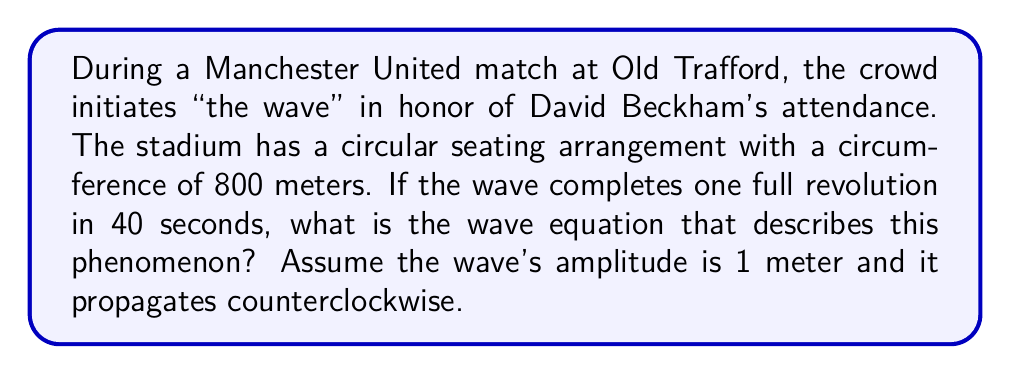What is the answer to this math problem? To derive the wave equation, we'll follow these steps:

1) First, we need to calculate the wave speed:
   $v = \frac{\text{distance}}{\text{time}} = \frac{800\text{ m}}{40\text{ s}} = 20\text{ m/s}$

2) The angular frequency $\omega$ is given by:
   $\omega = \frac{2\pi}{T} = \frac{2\pi}{40} = \frac{\pi}{20}\text{ rad/s}$

3) The wavenumber $k$ is:
   $k = \frac{2\pi}{\lambda} = \frac{2\pi}{800} = \frac{\pi}{400}\text{ rad/m}$

4) The general form of a traveling wave equation is:
   $y(x,t) = A \sin(kx \pm \omega t)$

   Where:
   - $A$ is the amplitude (1 meter in this case)
   - The negative sign in $\pm$ is used for waves traveling in the positive x-direction
   - The positive sign in $\pm$ is used for waves traveling in the negative x-direction

5) Since the wave is traveling counterclockwise (which we'll consider as the positive direction), we use the negative sign:

   $y(x,t) = 1 \sin(\frac{\pi}{400}x - \frac{\pi}{20}t)$

6) To express this in terms of position along the circumference ($x$) in meters and time ($t$) in seconds, we get:

   $y(x,t) = 1 \sin(\frac{\pi}{400}x - \frac{\pi}{20}t)$

This is the wave equation describing "the wave" in the stadium.
Answer: $y(x,t) = 1 \sin(\frac{\pi}{400}x - \frac{\pi}{20}t)$ 